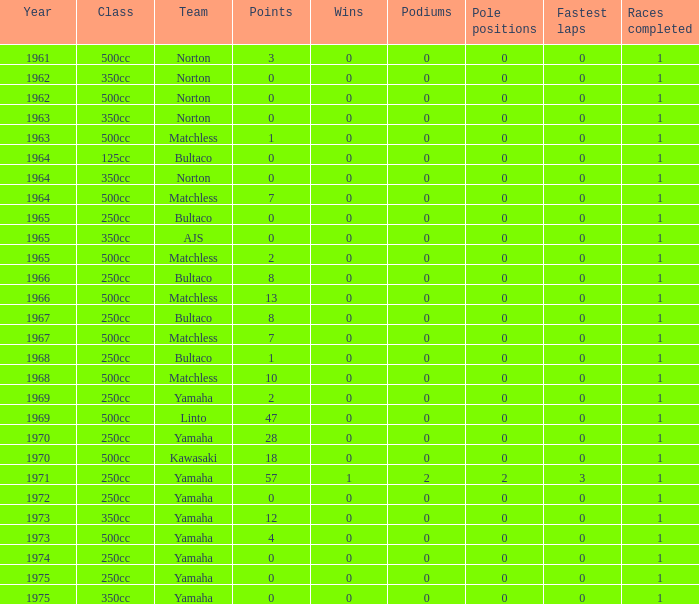What is the total number of points in 1975 for those with no victories? None. 